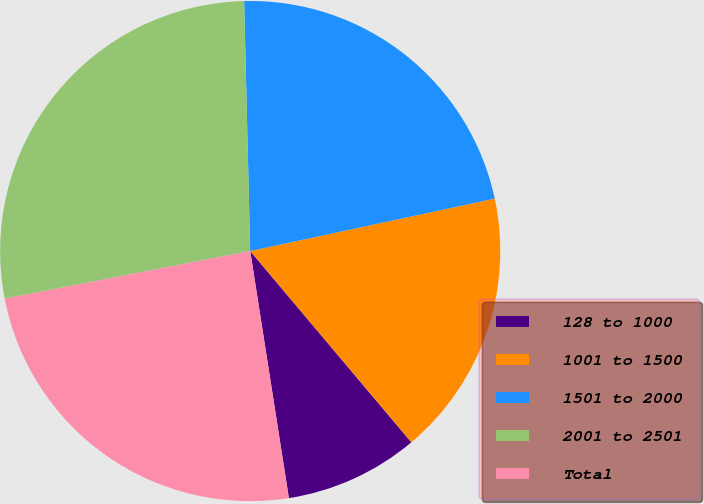Convert chart to OTSL. <chart><loc_0><loc_0><loc_500><loc_500><pie_chart><fcel>128 to 1000<fcel>1001 to 1500<fcel>1501 to 2000<fcel>2001 to 2501<fcel>Total<nl><fcel>8.67%<fcel>17.22%<fcel>22.02%<fcel>27.66%<fcel>24.42%<nl></chart> 